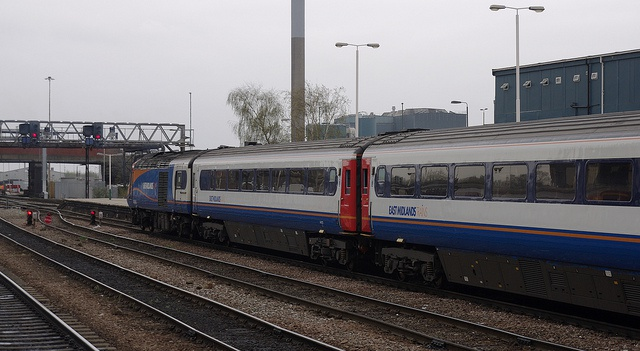Describe the objects in this image and their specific colors. I can see train in lightgray, black, gray, and navy tones, traffic light in lightgray, black, and gray tones, and traffic light in lightgray, black, gray, and darkblue tones in this image. 